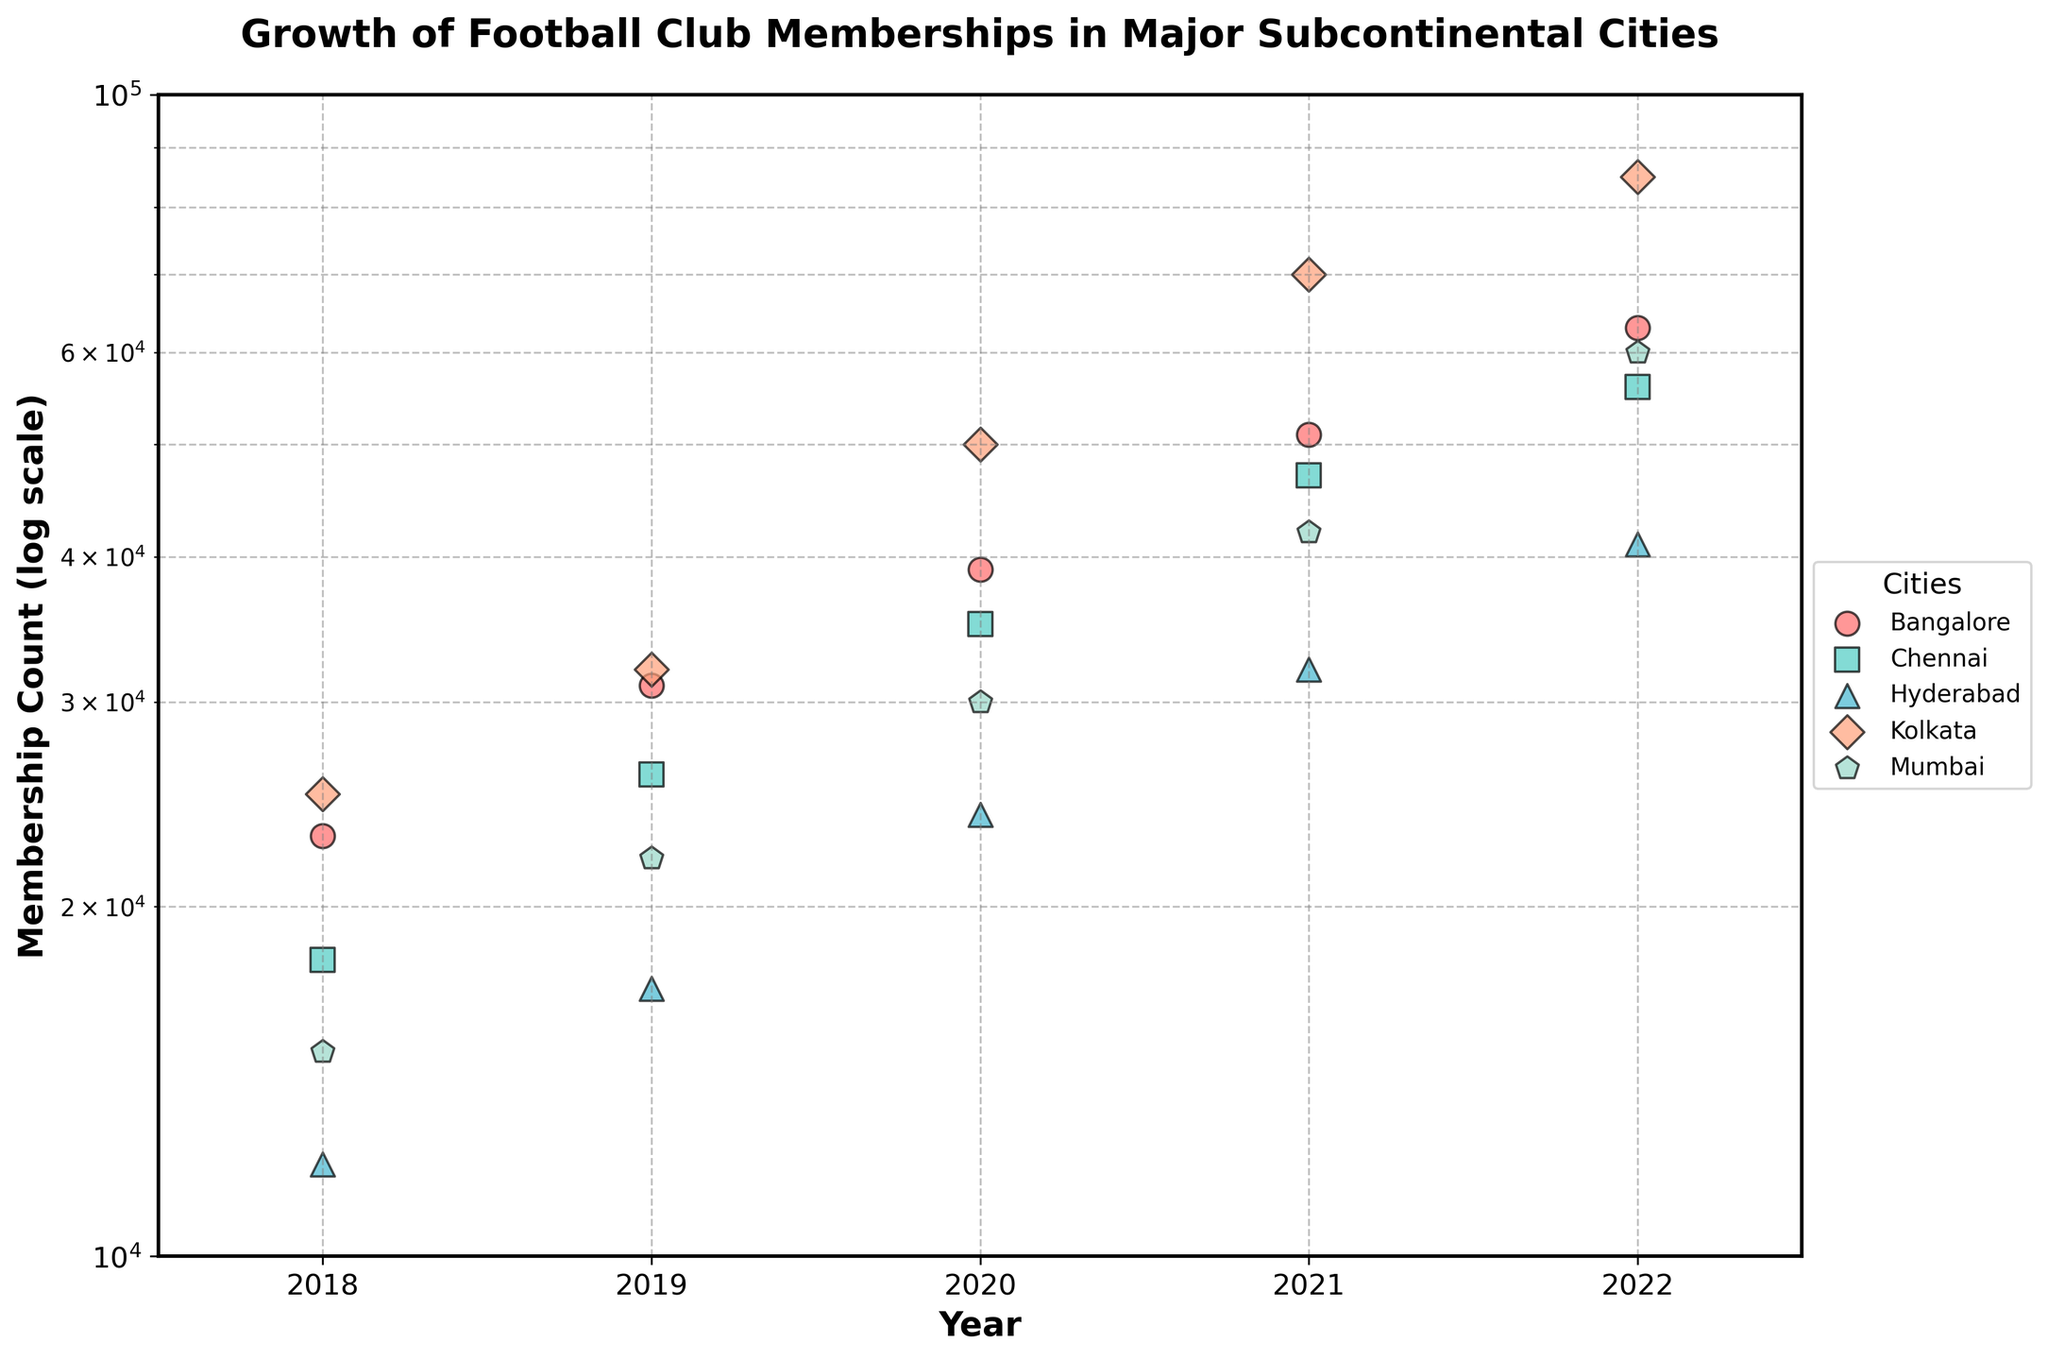What is the highest membership count for Mumbai City FC in the given period? By looking at the scatter points for Mumbai (usually of a specific color/marker), the maximum y-axis value (membership count) is 60,000 for the year 2022.
Answer: 60,000 Which city had the largest growth in membership from 2018 to 2022? Compare the initial (2018) and final (2022) membership counts across all cities. Kolkata (ATK Mohun Bagan) grew from 25,000 in 2018 to 85,000 in 2022, the largest increase by 60,000.
Answer: Kolkata How did the membership of Hyderabad FC evolve over the years? Focus on the scatter points for Hyderabad and observe their y-axis values for each year from 2018 to 2022, which increase from 12,000 to 41,000.
Answer: Increased steadily Which club had the smallest membership count in 2018? Check the scatter points for the year 2018 and find the lowest y-axis value, which is 12,000 for Hyderabad FC.
Answer: Hyderabad FC Are there any cities where the membership count doubled over the given period? Inspect cities' scatter points over the years and see if any city's 2022 membership counts surpass double of their 2018 counts. Mumbai City FC had 15,000 in 2018 and 60,000 in 2022, more than doubled.
Answer: Mumbai Which year shows the highest overall growth in memberships across all cities? Look at the overall increase in y-values between two consecutive years across cities. Summing growth from 2021 to 2022 yields the highest increase.
Answer: 2021-2022 How does the membership count of Bengaluru FC in 2020 compare to Chennaiyin FC in the same year? Compare the specific scatter points for both Bengaluru FC and Chennaiyin FC for the year 2020. Bengaluru FC has around 39,000 compared to Chennaiyin FC’s 35,000.
Answer: Bengaluru FC has higher Is there a general trend in the membership counts for all cities from 2018 to 2022? Observe whether the scatter points for all cities show an upward movement from 2018 to 2022, indicating a general increase in membership counts across cities.
Answer: Increasing trend What is the range of membership counts for Chennaiyin FC from 2018 to 2022? Identify the minimum and maximum y-axis values for Chennaiyin FC’s scatter points between 2018 and 2022. The range is from 18,000 to 56,000.
Answer: 18,000 to 56,000 